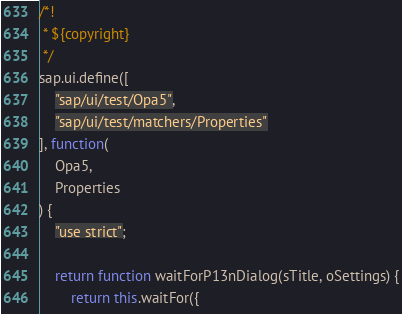<code> <loc_0><loc_0><loc_500><loc_500><_JavaScript_>/*!
 * ${copyright}
 */
sap.ui.define([
	"sap/ui/test/Opa5",
	"sap/ui/test/matchers/Properties"
], function(
	Opa5,
	Properties
) {
	"use strict";

	return function waitForP13nDialog(sTitle, oSettings) {
		return this.waitFor({</code> 